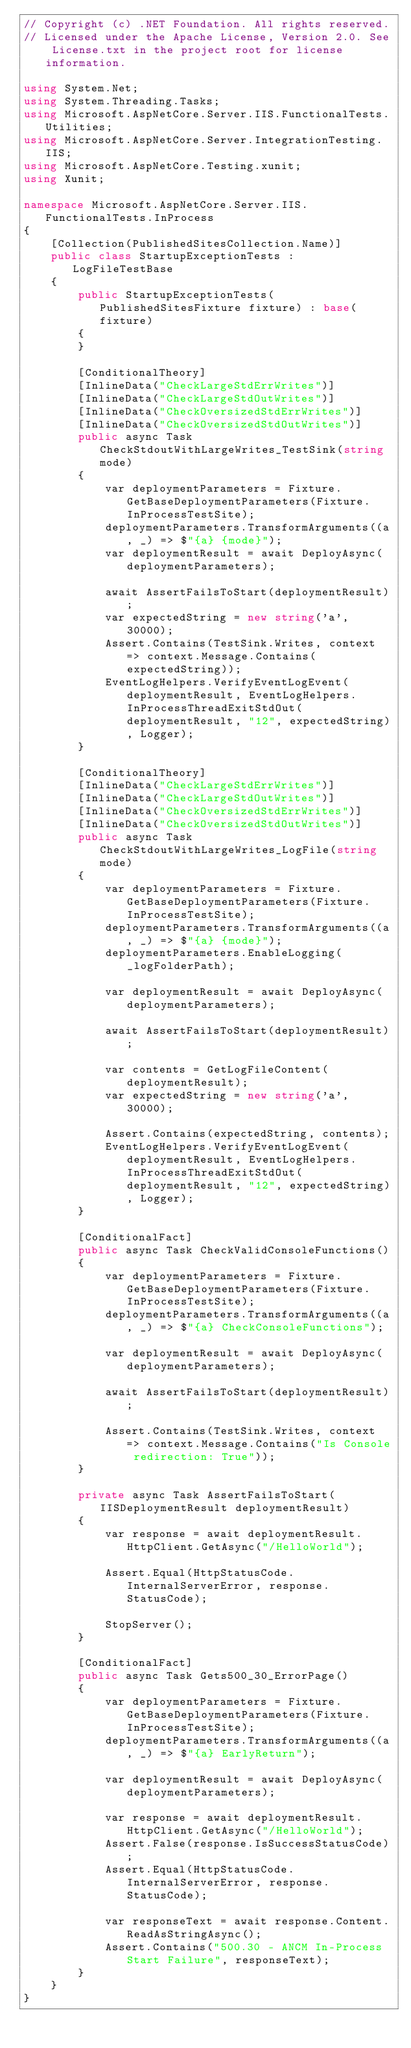<code> <loc_0><loc_0><loc_500><loc_500><_C#_>// Copyright (c) .NET Foundation. All rights reserved.
// Licensed under the Apache License, Version 2.0. See License.txt in the project root for license information.

using System.Net;
using System.Threading.Tasks;
using Microsoft.AspNetCore.Server.IIS.FunctionalTests.Utilities;
using Microsoft.AspNetCore.Server.IntegrationTesting.IIS;
using Microsoft.AspNetCore.Testing.xunit;
using Xunit;

namespace Microsoft.AspNetCore.Server.IIS.FunctionalTests.InProcess
{
    [Collection(PublishedSitesCollection.Name)]
    public class StartupExceptionTests : LogFileTestBase
    {
        public StartupExceptionTests(PublishedSitesFixture fixture) : base(fixture)
        {
        }

        [ConditionalTheory]
        [InlineData("CheckLargeStdErrWrites")]
        [InlineData("CheckLargeStdOutWrites")]
        [InlineData("CheckOversizedStdErrWrites")]
        [InlineData("CheckOversizedStdOutWrites")]
        public async Task CheckStdoutWithLargeWrites_TestSink(string mode)
        {
            var deploymentParameters = Fixture.GetBaseDeploymentParameters(Fixture.InProcessTestSite);
            deploymentParameters.TransformArguments((a, _) => $"{a} {mode}");
            var deploymentResult = await DeployAsync(deploymentParameters);

            await AssertFailsToStart(deploymentResult);
            var expectedString = new string('a', 30000);
            Assert.Contains(TestSink.Writes, context => context.Message.Contains(expectedString));
            EventLogHelpers.VerifyEventLogEvent(deploymentResult, EventLogHelpers.InProcessThreadExitStdOut(deploymentResult, "12", expectedString), Logger);
        }

        [ConditionalTheory]
        [InlineData("CheckLargeStdErrWrites")]
        [InlineData("CheckLargeStdOutWrites")]
        [InlineData("CheckOversizedStdErrWrites")]
        [InlineData("CheckOversizedStdOutWrites")]
        public async Task CheckStdoutWithLargeWrites_LogFile(string mode)
        {
            var deploymentParameters = Fixture.GetBaseDeploymentParameters(Fixture.InProcessTestSite);
            deploymentParameters.TransformArguments((a, _) => $"{a} {mode}");
            deploymentParameters.EnableLogging(_logFolderPath);

            var deploymentResult = await DeployAsync(deploymentParameters);

            await AssertFailsToStart(deploymentResult);

            var contents = GetLogFileContent(deploymentResult);
            var expectedString = new string('a', 30000);

            Assert.Contains(expectedString, contents);
            EventLogHelpers.VerifyEventLogEvent(deploymentResult, EventLogHelpers.InProcessThreadExitStdOut(deploymentResult, "12", expectedString), Logger);
        }

        [ConditionalFact]
        public async Task CheckValidConsoleFunctions()
        {
            var deploymentParameters = Fixture.GetBaseDeploymentParameters(Fixture.InProcessTestSite);
            deploymentParameters.TransformArguments((a, _) => $"{a} CheckConsoleFunctions");

            var deploymentResult = await DeployAsync(deploymentParameters);

            await AssertFailsToStart(deploymentResult);

            Assert.Contains(TestSink.Writes, context => context.Message.Contains("Is Console redirection: True"));
        }

        private async Task AssertFailsToStart(IISDeploymentResult deploymentResult)
        {
            var response = await deploymentResult.HttpClient.GetAsync("/HelloWorld");

            Assert.Equal(HttpStatusCode.InternalServerError, response.StatusCode);

            StopServer();
        }

        [ConditionalFact]
        public async Task Gets500_30_ErrorPage()
        {
            var deploymentParameters = Fixture.GetBaseDeploymentParameters(Fixture.InProcessTestSite);
            deploymentParameters.TransformArguments((a, _) => $"{a} EarlyReturn");

            var deploymentResult = await DeployAsync(deploymentParameters);

            var response = await deploymentResult.HttpClient.GetAsync("/HelloWorld");
            Assert.False(response.IsSuccessStatusCode);
            Assert.Equal(HttpStatusCode.InternalServerError, response.StatusCode);

            var responseText = await response.Content.ReadAsStringAsync();
            Assert.Contains("500.30 - ANCM In-Process Start Failure", responseText);
        }
    }
}
</code> 